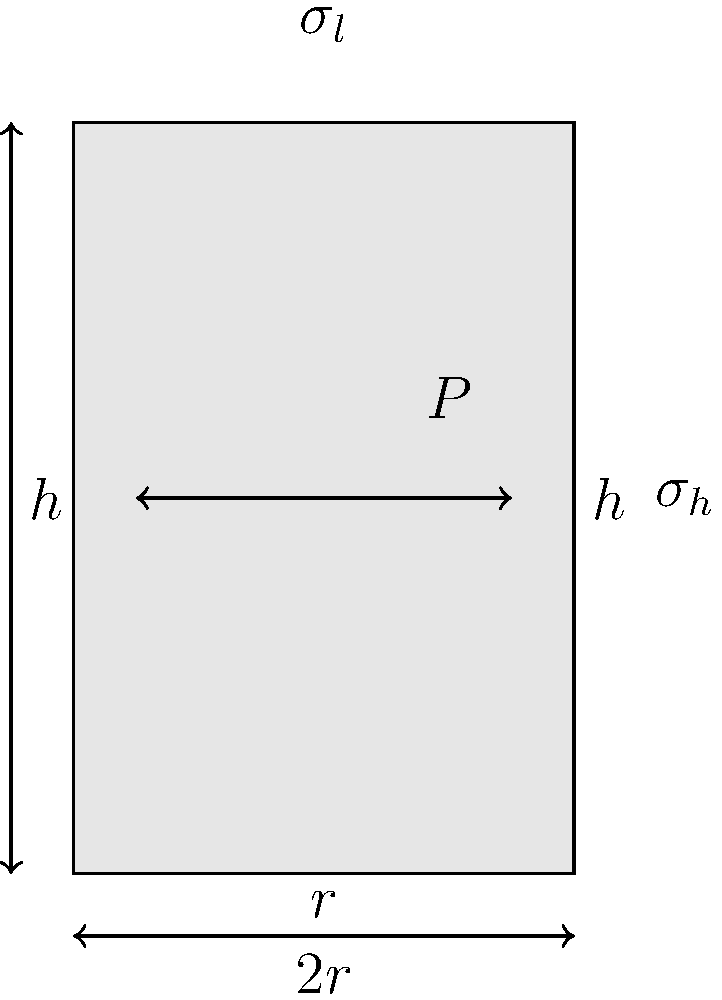A cylindrical pressure vessel with an internal radius $r = 0.5$ m, height $h = 3$ m, and wall thickness $t = 0.02$ m is subjected to an internal pressure $P = 2$ MPa. Calculate the hoop stress ($\sigma_h$) and longitudinal stress ($\sigma_l$) in the vessel wall. Assume the vessel is thin-walled (i.e., $r/t \geq 10$). To calculate the stress distribution in a thin-walled cylindrical pressure vessel, we can use the following steps:

1. Verify if the vessel is thin-walled:
   $r/t = 0.5 / 0.02 = 25 \geq 10$, so the thin-wall assumption is valid.

2. Calculate the hoop stress ($\sigma_h$):
   The hoop stress is given by the formula:
   $$\sigma_h = \frac{Pr}{t}$$
   where $P$ is the internal pressure, $r$ is the radius, and $t$ is the wall thickness.
   
   Substituting the values:
   $$\sigma_h = \frac{2 \times 10^6 \times 0.5}{0.02} = 50 \times 10^6 \text{ Pa} = 50 \text{ MPa}$$

3. Calculate the longitudinal stress ($\sigma_l$):
   The longitudinal stress is given by the formula:
   $$\sigma_l = \frac{Pr}{2t}$$
   
   Substituting the values:
   $$\sigma_l = \frac{2 \times 10^6 \times 0.5}{2 \times 0.02} = 25 \times 10^6 \text{ Pa} = 25 \text{ MPa}$$

4. Note that the hoop stress is twice the longitudinal stress for a thin-walled cylindrical pressure vessel.
Answer: $\sigma_h = 50 \text{ MPa}$, $\sigma_l = 25 \text{ MPa}$ 